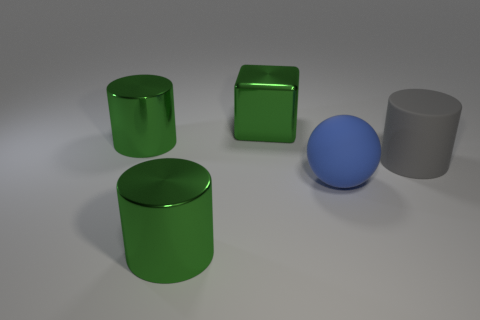Add 2 big blue matte balls. How many objects exist? 7 Subtract all balls. How many objects are left? 4 Add 4 green metallic cylinders. How many green metallic cylinders are left? 6 Add 1 spheres. How many spheres exist? 2 Subtract 0 blue blocks. How many objects are left? 5 Subtract all big gray matte cylinders. Subtract all large blue objects. How many objects are left? 3 